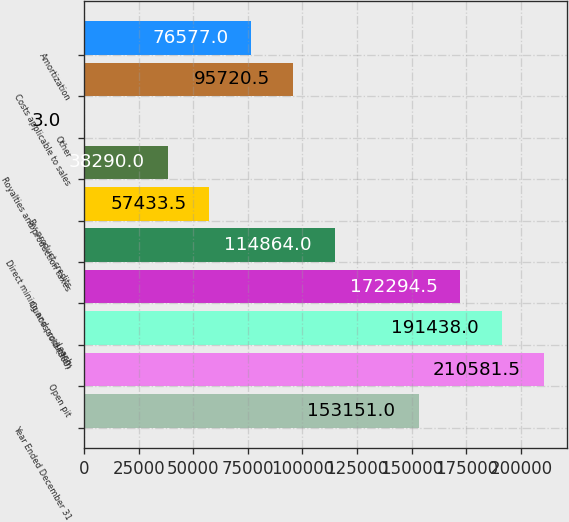Convert chart. <chart><loc_0><loc_0><loc_500><loc_500><bar_chart><fcel>Year Ended December 31<fcel>Open pit<fcel>Leach<fcel>Ounces sold (000)<fcel>Direct mining and production<fcel>By-product credits<fcel>Royalties and production taxes<fcel>Other<fcel>Costs applicable to sales<fcel>Amortization<nl><fcel>153151<fcel>210582<fcel>191438<fcel>172294<fcel>114864<fcel>57433.5<fcel>38290<fcel>3<fcel>95720.5<fcel>76577<nl></chart> 